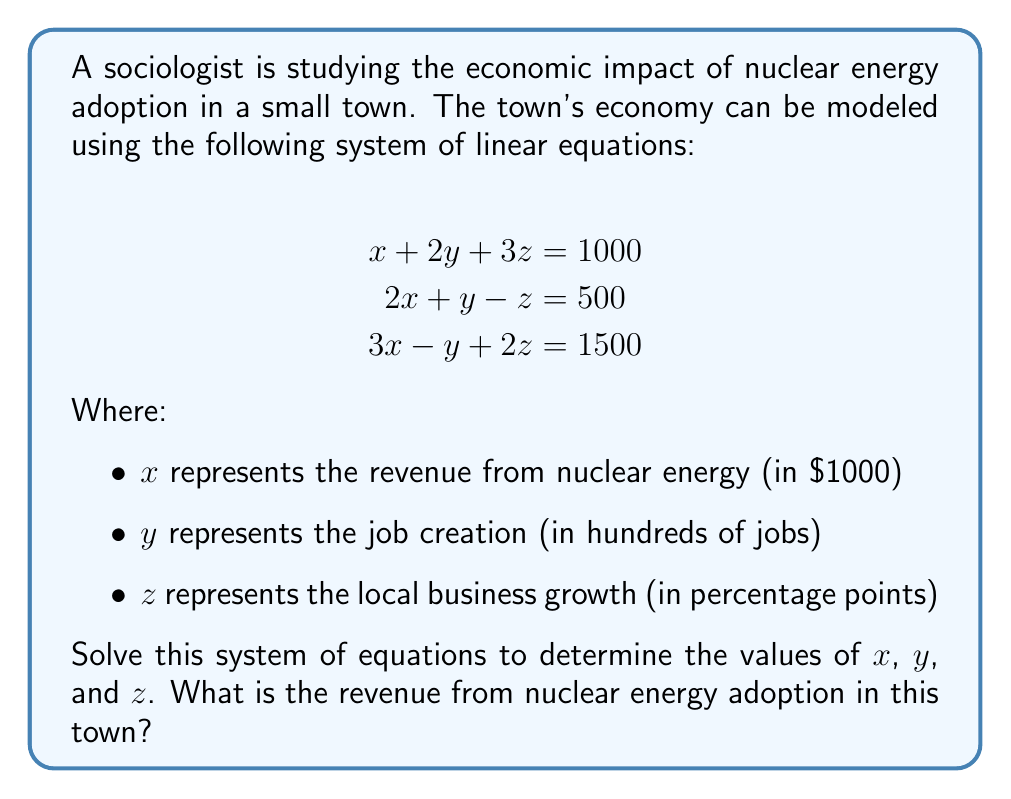Could you help me with this problem? To solve this system of linear equations, we can use the Gaussian elimination method:

Step 1: Write the augmented matrix
$$\begin{bmatrix}
1 & 2 & 3 & | & 1000 \\
2 & 1 & -1 & | & 500 \\
3 & -1 & 2 & | & 1500
\end{bmatrix}$$

Step 2: Eliminate $x$ from the second and third rows
Multiply row 1 by -2 and add to row 2:
$$\begin{bmatrix}
1 & 2 & 3 & | & 1000 \\
0 & -3 & -7 & | & -1500 \\
3 & -1 & 2 & | & 1500
\end{bmatrix}$$

Multiply row 1 by -3 and add to row 3:
$$\begin{bmatrix}
1 & 2 & 3 & | & 1000 \\
0 & -3 & -7 & | & -1500 \\
0 & -7 & -7 & | & -1500
\end{bmatrix}$$

Step 3: Eliminate $y$ from the third row
Multiply row 2 by $\frac{7}{3}$ and add to row 3:
$$\begin{bmatrix}
1 & 2 & 3 & | & 1000 \\
0 & -3 & -7 & | & -1500 \\
0 & 0 & -\frac{28}{3} & | & -2000
\end{bmatrix}$$

Step 4: Back-substitution
From the last row: $z = \frac{2000}{\frac{28}{3}} = \frac{3000}{14} = 214.29$

Substitute $z$ into the second row:
$-3y - 7(214.29) = -1500$
$-3y = -1500 + 1500$
$y = 0$

Substitute $y$ and $z$ into the first row:
$x + 2(0) + 3(214.29) = 1000$
$x = 1000 - 642.87 = 357.13$

Therefore, $x \approx 357.13$, which represents the revenue from nuclear energy in thousands of dollars.
Answer: $357,130 